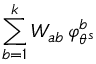Convert formula to latex. <formula><loc_0><loc_0><loc_500><loc_500>\sum _ { b = 1 } ^ { k } W _ { a b } \, \varphi _ { \theta ^ { s } } ^ { b }</formula> 